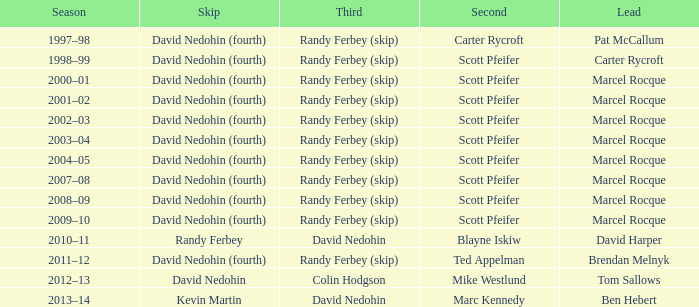Which triad has a duad of scott pfeifer? Randy Ferbey (skip), Randy Ferbey (skip), Randy Ferbey (skip), Randy Ferbey (skip), Randy Ferbey (skip), Randy Ferbey (skip), Randy Ferbey (skip), Randy Ferbey (skip), Randy Ferbey (skip). 